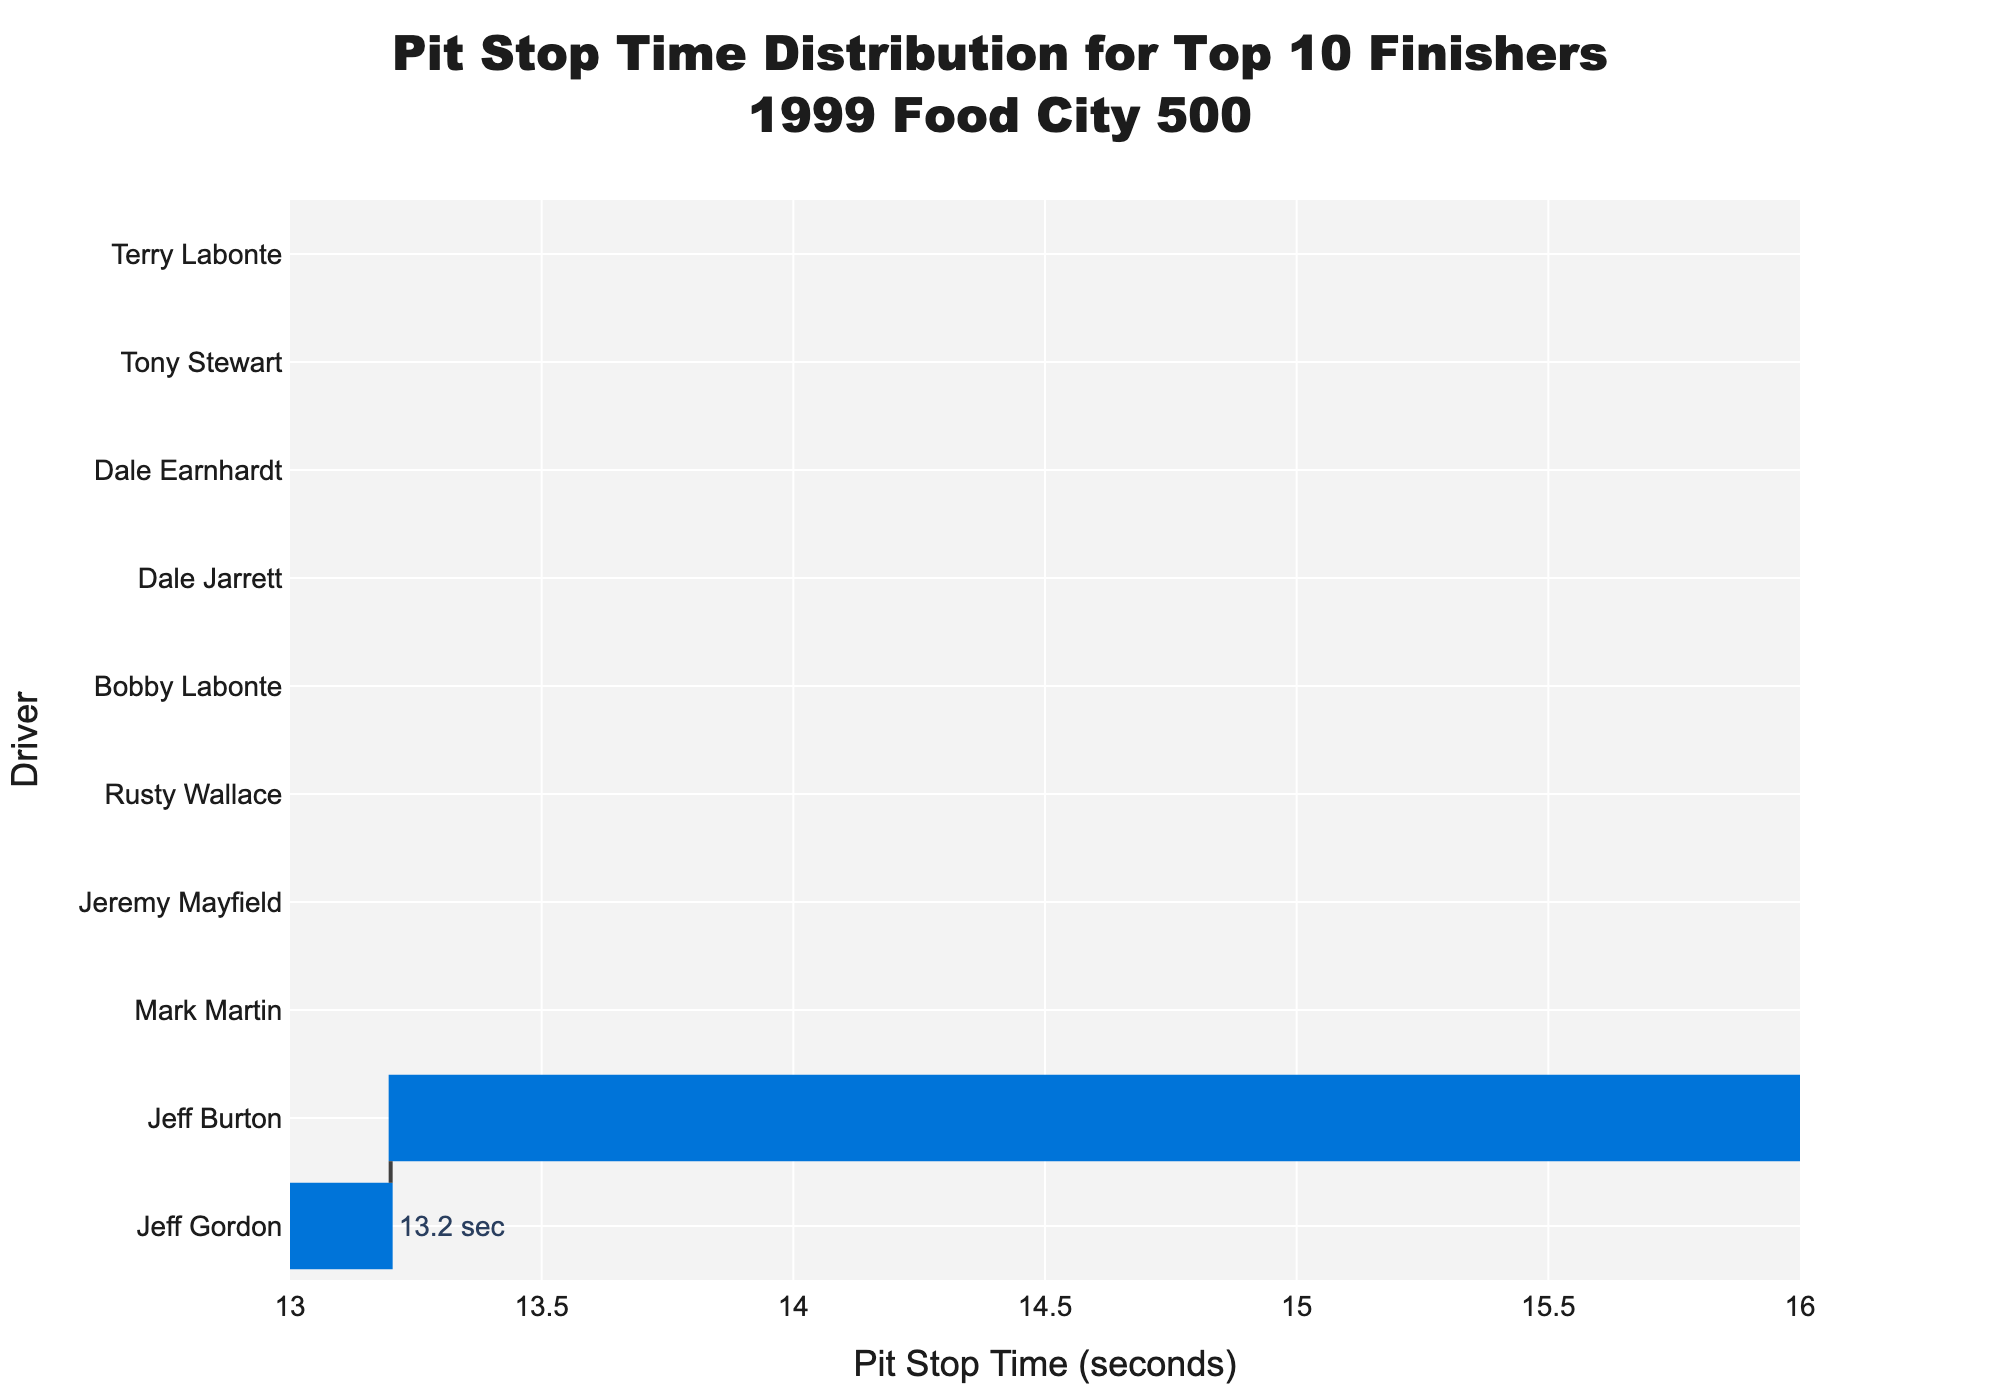What is the title of the chart? Read the text at the top of the chart, which is typically larger and more prominent.
Answer: Pit Stop Time Distribution for Top 10 Finishers 1999 Food City 500 Which driver had the fastest pit stop time? Identify the driver associated with the leftmost bar on the chart since it is ordered by lowest to highest pit stop time.
Answer: Jeff Gordon What is the pit stop time for Tony Stewart? Find the bar associated with Tony Stewart and read the value displayed next to it.
Answer: 15.1 sec How many drivers had a pit stop time below 14 seconds? Count the number of bars that have values less than 14 seconds.
Answer: 4 What is the difference in pit stop time between the fastest and the slowest driver? Subtract the pit stop time of the fastest driver (leftmost bar) from the pit stop time of the slowest driver (rightmost bar).
Answer: 2.1 sec Which driver had the longest pit stop time? Identify the driver associated with the rightmost bar on the chart since it is ordered by lowest to highest pit stop time.
Answer: Terry Labonte What is the average pit stop time of the top 10 finishers? Sum all the pit stop times listed and divide by the number of drivers (10).
Answer: (13.2 + 14.5 + 13.8 + 15.1 + 14.3 + 13.6 + 14.9 + 14.1 + 15.3 + 13.9) / 10 = 14.27 sec Who had a pit stop time closest to 14 seconds? Look for the bar with a pit stop time that is closest to 14 seconds and identify the associated driver.
Answer: Rusty Wallace How many drivers had pit stop times between 13.5 seconds and 14.5 seconds inclusive? Count the number of bars with values between 13.5 and 14.5 seconds inclusive.
Answer: 5 Which drivers' pit stop times are labeled in blue on the chart? Identify the drivers associated with the bars colored in blue.
Answer: Jeff Gordon, Mark Martin, Jeff Burton, Jeremy Mayfield 